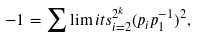Convert formula to latex. <formula><loc_0><loc_0><loc_500><loc_500>- 1 = { \sum \lim i t s _ { i = 2 } ^ { 2 ^ { k } } ( } p _ { i } p _ { 1 } ^ { - 1 } ) ^ { 2 } ,</formula> 